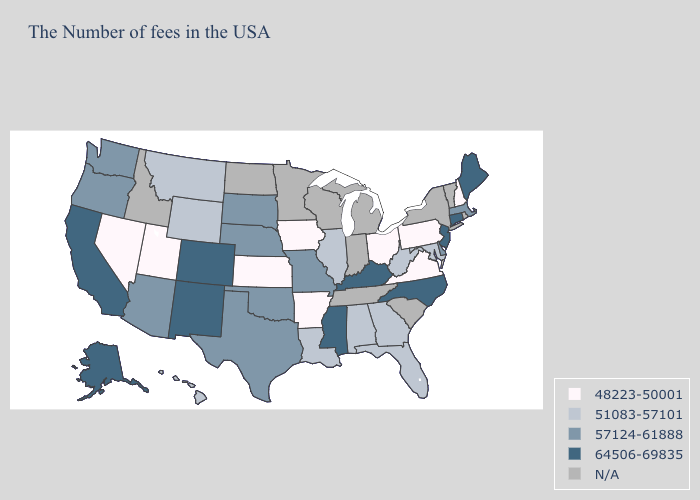Name the states that have a value in the range 57124-61888?
Write a very short answer. Massachusetts, Delaware, Missouri, Nebraska, Oklahoma, Texas, South Dakota, Arizona, Washington, Oregon. What is the lowest value in the Northeast?
Short answer required. 48223-50001. Name the states that have a value in the range N/A?
Short answer required. Rhode Island, Vermont, New York, South Carolina, Michigan, Indiana, Tennessee, Wisconsin, Minnesota, North Dakota, Idaho. What is the lowest value in the MidWest?
Answer briefly. 48223-50001. What is the value of Hawaii?
Write a very short answer. 51083-57101. Does New Hampshire have the highest value in the Northeast?
Write a very short answer. No. Name the states that have a value in the range 51083-57101?
Give a very brief answer. Maryland, West Virginia, Florida, Georgia, Alabama, Illinois, Louisiana, Wyoming, Montana, Hawaii. Among the states that border Oklahoma , which have the lowest value?
Keep it brief. Arkansas, Kansas. Does Mississippi have the lowest value in the USA?
Concise answer only. No. Does the first symbol in the legend represent the smallest category?
Write a very short answer. Yes. What is the value of Indiana?
Write a very short answer. N/A. Among the states that border Nevada , does California have the highest value?
Keep it brief. Yes. Name the states that have a value in the range 64506-69835?
Quick response, please. Maine, Connecticut, New Jersey, North Carolina, Kentucky, Mississippi, Colorado, New Mexico, California, Alaska. What is the value of New Hampshire?
Write a very short answer. 48223-50001. Name the states that have a value in the range N/A?
Quick response, please. Rhode Island, Vermont, New York, South Carolina, Michigan, Indiana, Tennessee, Wisconsin, Minnesota, North Dakota, Idaho. 